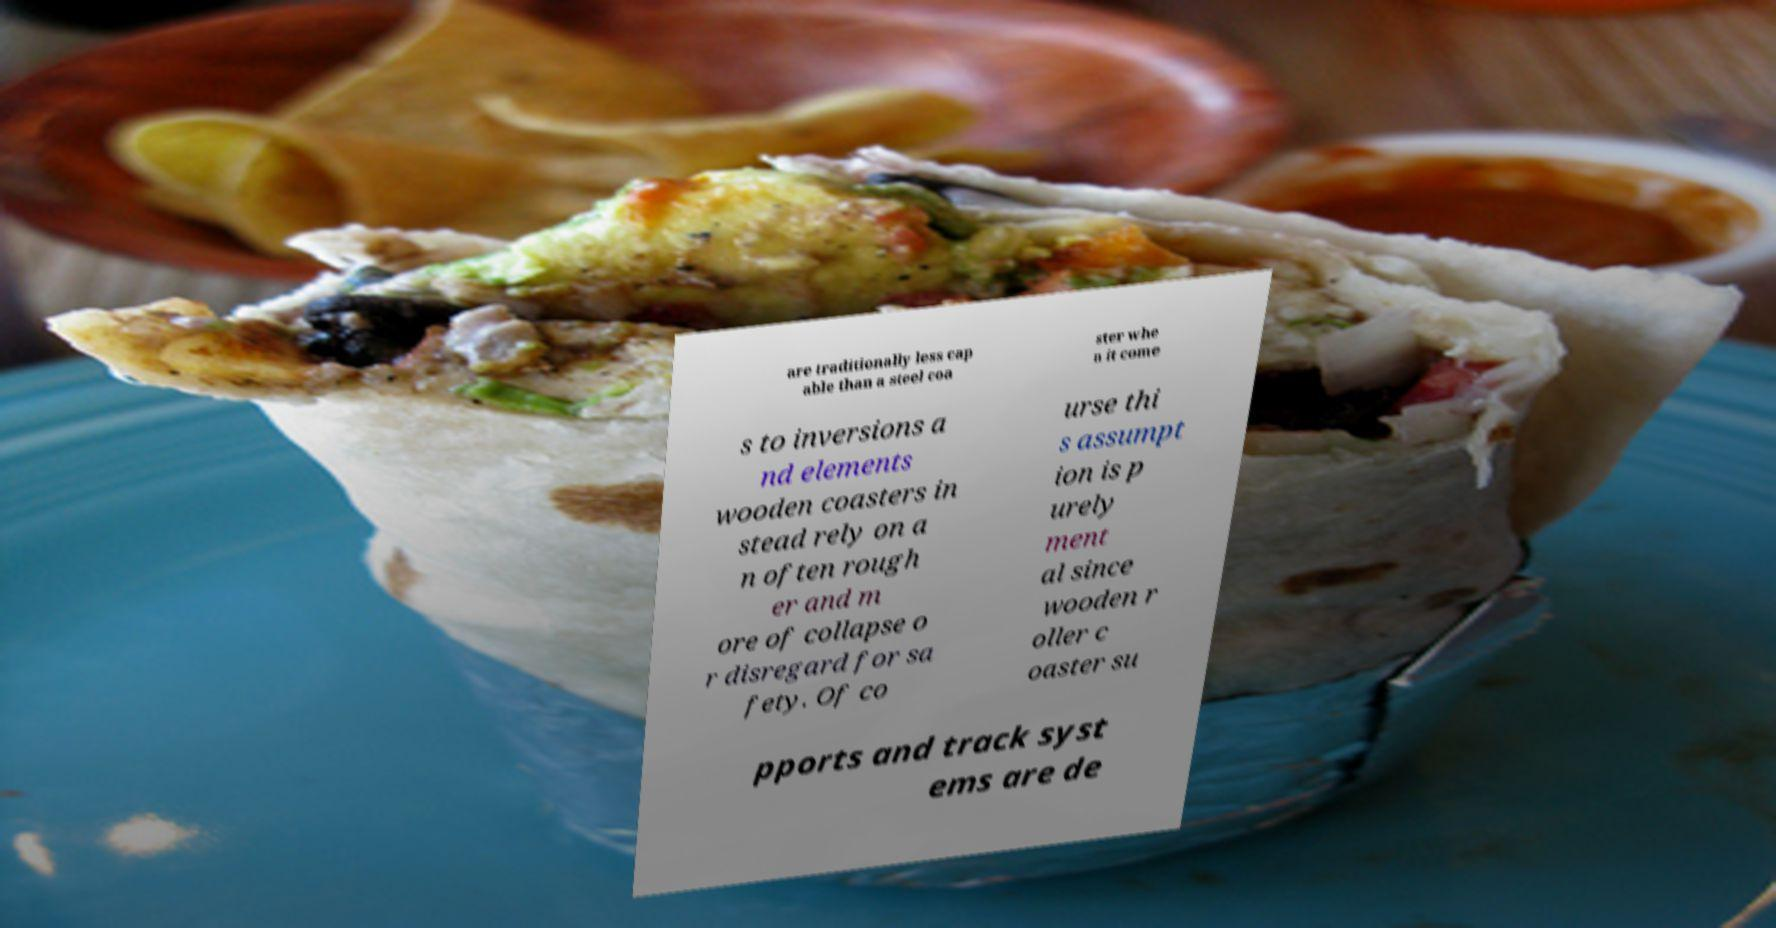Can you read and provide the text displayed in the image?This photo seems to have some interesting text. Can you extract and type it out for me? are traditionally less cap able than a steel coa ster whe n it come s to inversions a nd elements wooden coasters in stead rely on a n often rough er and m ore of collapse o r disregard for sa fety. Of co urse thi s assumpt ion is p urely ment al since wooden r oller c oaster su pports and track syst ems are de 